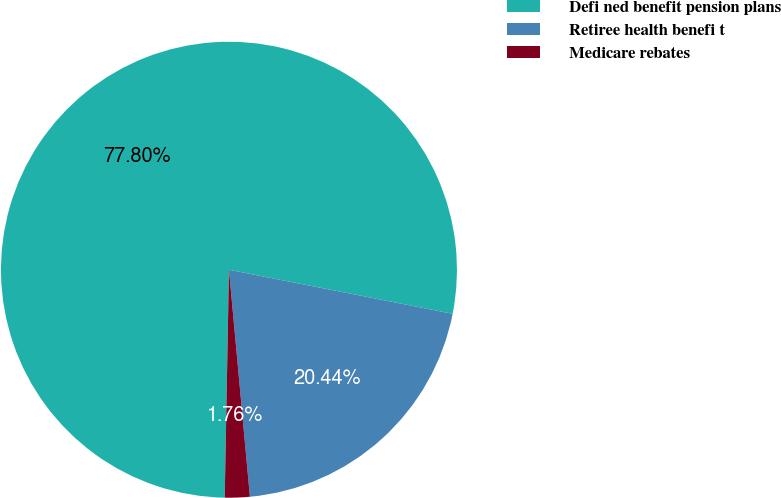<chart> <loc_0><loc_0><loc_500><loc_500><pie_chart><fcel>Defi ned benefit pension plans<fcel>Retiree health benefi t<fcel>Medicare rebates<nl><fcel>77.8%<fcel>20.44%<fcel>1.76%<nl></chart> 